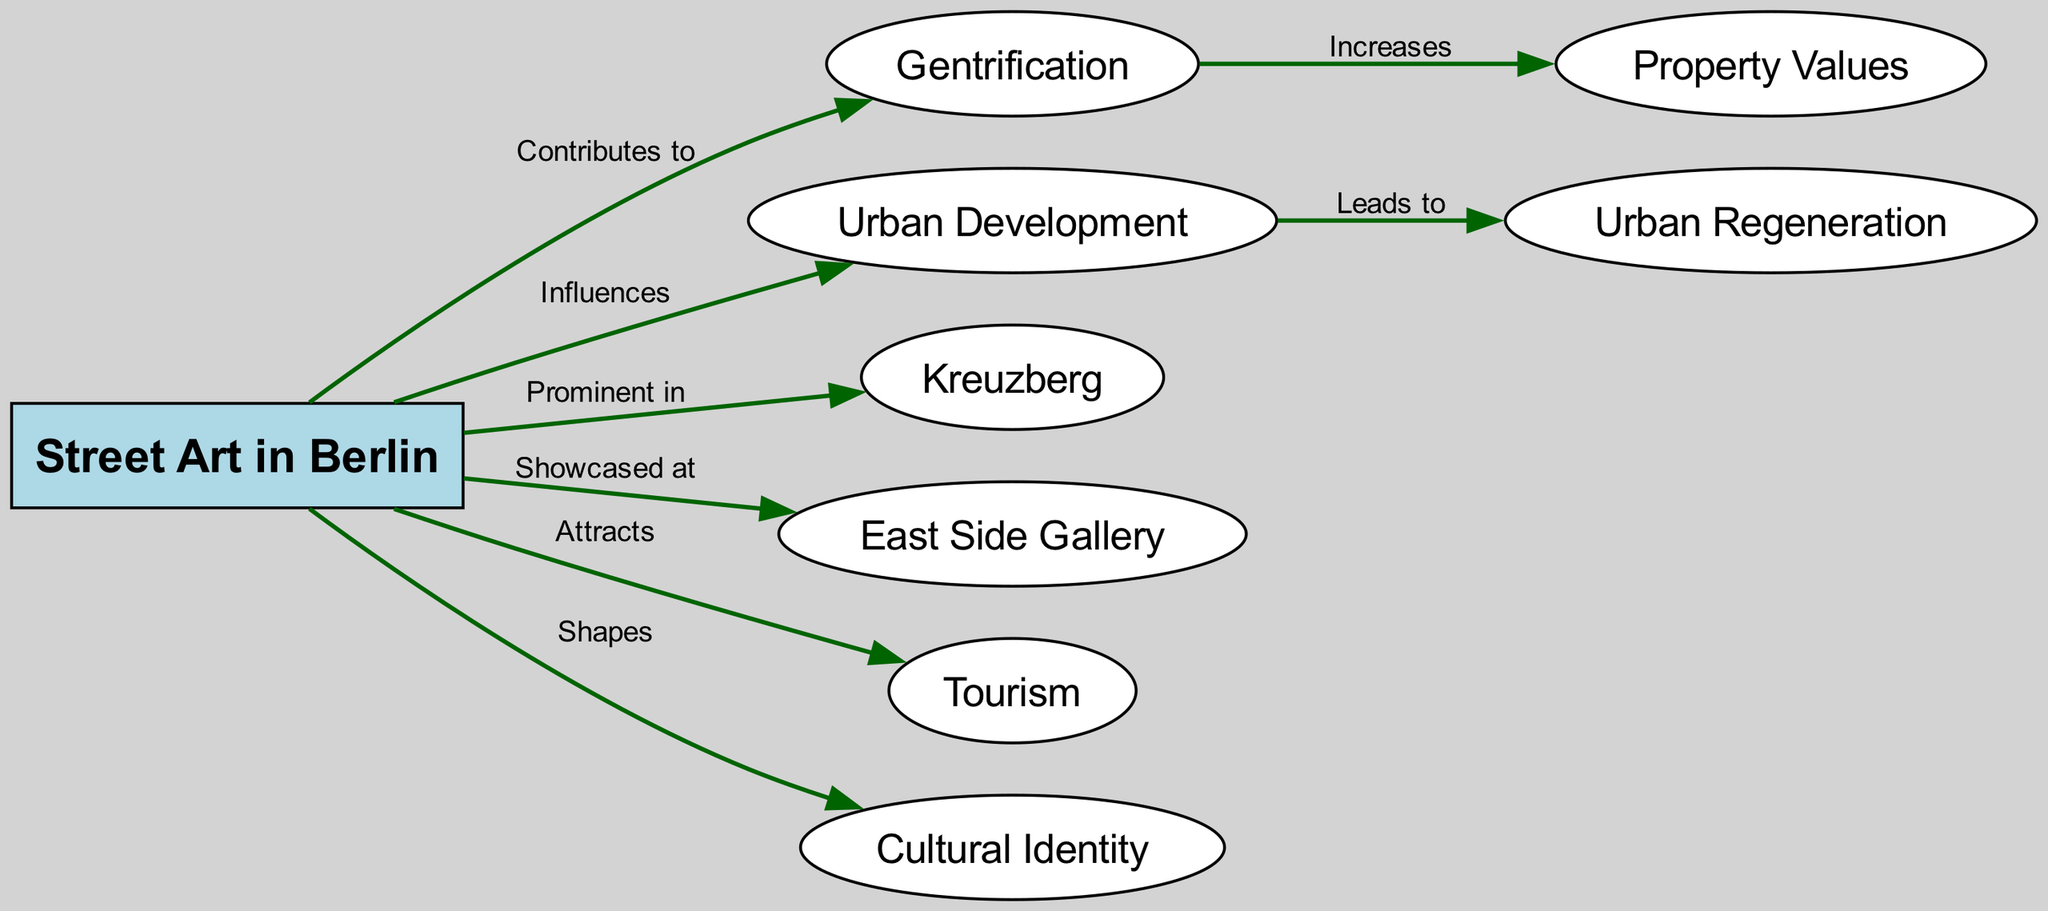What is the main subject of the concept map? The main subject of the concept map is indicated by the central node labeled "Street Art in Berlin" which connects to other concepts related to it.
Answer: Street Art in Berlin How many nodes are present in the diagram? By counting the node entries in the data, there are a total of eight nodes displayed in the diagram.
Answer: 8 Which concept is prominently featured in the context of street art? The diagram shows an edge labeled "Prominent in" connecting "Street Art" to "Kreuzberg," highlighting this urban area as central to the discussion of street art.
Answer: Kreuzberg What relationship exists between street art and tourism? The diagram indicates an edge labeled "Attracts," which means that street art plays a role in attracting tourism in Berlin.
Answer: Attracts How does gentrification affect property values, according to the diagram? The diagram connects "Gentrification" to "Property Values" with an edge labeled "Increases," suggesting that gentrification leads to an increase in property values.
Answer: Increases What effect does street art have on cultural identity? The relationship labeled "Shapes" between "Street Art" and "Cultural Identity" in the diagram emphasizes that street art influences or shapes cultural identity in Berlin.
Answer: Shapes What does urban development lead to, based on the diagram? The connection labeled "Leads to" from "Urban Development" to "Urban Regeneration" indicates that urban development is a precursor or cause of urban regeneration.
Answer: Urban Regeneration How is street art showcased in Berlin? The diagram highlights the connection between "Street Art" and "East Side Gallery" with the label "Showcased at," signifying that it is exhibited at this prominent site.
Answer: East Side Gallery What impact does street art have on gentrification? The diagram has a directed edge labeled "Contributes to," indicating that street art plays a contributing role in the process of gentrification.
Answer: Contributes to 